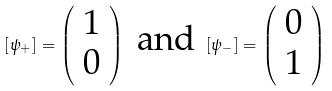Convert formula to latex. <formula><loc_0><loc_0><loc_500><loc_500>[ \psi _ { + } ] = \left ( \begin{array} { c } 1 \\ 0 \end{array} \right ) \text { and } [ \psi _ { - } ] = \left ( \begin{array} { c } 0 \\ 1 \end{array} \right )</formula> 